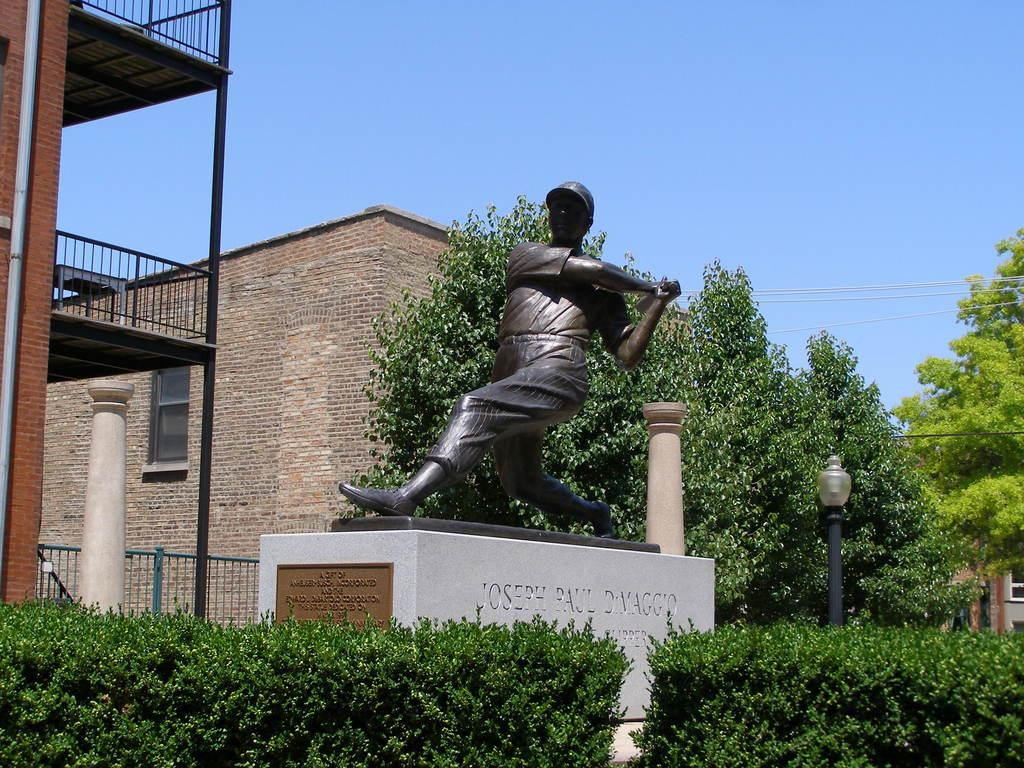What type of structures can be seen in the image? There are buildings in the image. What natural elements are present in the image? There are trees and plants in the image. What man-made objects can be seen in the image? There are poles and a pole light in the image. Is there any artwork or sculpture in the image? Yes, there is a statue in the image. Are there any words or letters in the image? Yes, there is text in the image. What is the color of the sky in the image? The sky is blue in the image. Where is the butter located in the image? There is no butter present in the image. What type of cave can be seen in the image? There is no cave present in the image. 